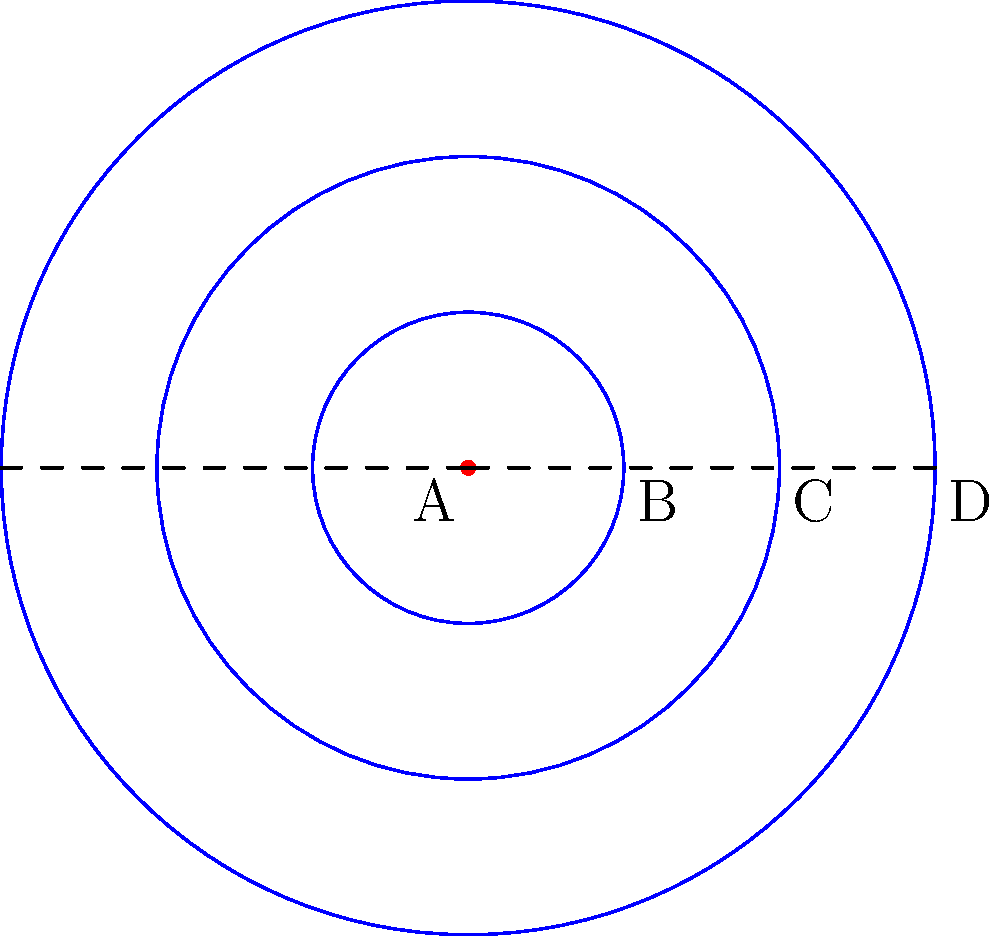In the diagram above, point A represents an ethical decision, and the concentric circles represent the ripple effects of that decision over time. If the area between circles B and C represents the immediate consequences, and the area between circles C and D represents long-term effects, what is the ratio of the long-term effects area to the immediate consequences area? To solve this problem, we need to follow these steps:

1. Recognize that the areas we're comparing are the areas between concentric circles.

2. Recall the formula for the area of a circle: $A = \pi r^2$

3. The area between two concentric circles is the difference of their areas:
   $A_{between} = \pi r_{outer}^2 - \pi r_{inner}^2 = \pi(r_{outer}^2 - r_{inner}^2)$

4. Let's assign variables:
   $r_B = 1$, $r_C = 2$, $r_D = 3$ (based on the given radii)

5. Calculate the area of immediate consequences (between B and C):
   $A_{BC} = \pi(r_C^2 - r_B^2) = \pi(2^2 - 1^2) = \pi(4 - 1) = 3\pi$

6. Calculate the area of long-term effects (between C and D):
   $A_{CD} = \pi(r_D^2 - r_C^2) = \pi(3^2 - 2^2) = \pi(9 - 4) = 5\pi$

7. Calculate the ratio of long-term effects to immediate consequences:
   $\text{Ratio} = \frac{A_{CD}}{A_{BC}} = \frac{5\pi}{3\pi} = \frac{5}{3}$

Therefore, the ratio of the long-term effects area to the immediate consequences area is 5:3.
Answer: 5:3 